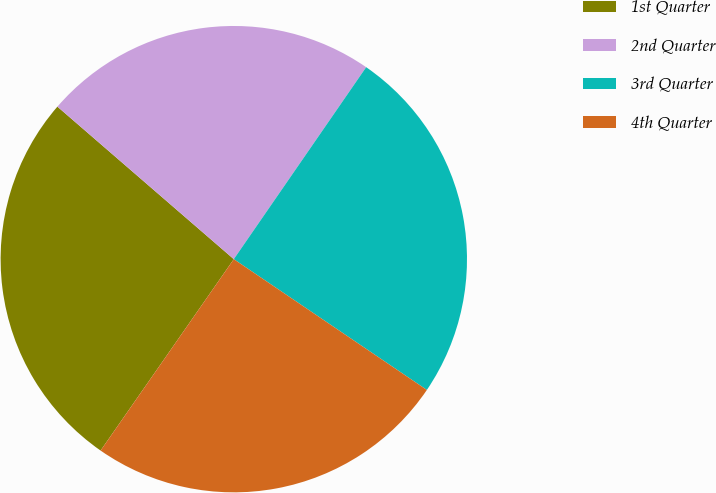Convert chart. <chart><loc_0><loc_0><loc_500><loc_500><pie_chart><fcel>1st Quarter<fcel>2nd Quarter<fcel>3rd Quarter<fcel>4th Quarter<nl><fcel>26.67%<fcel>23.26%<fcel>24.87%<fcel>25.2%<nl></chart> 